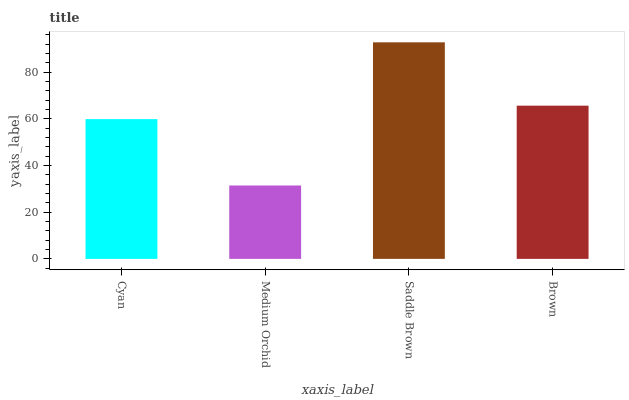Is Medium Orchid the minimum?
Answer yes or no. Yes. Is Saddle Brown the maximum?
Answer yes or no. Yes. Is Saddle Brown the minimum?
Answer yes or no. No. Is Medium Orchid the maximum?
Answer yes or no. No. Is Saddle Brown greater than Medium Orchid?
Answer yes or no. Yes. Is Medium Orchid less than Saddle Brown?
Answer yes or no. Yes. Is Medium Orchid greater than Saddle Brown?
Answer yes or no. No. Is Saddle Brown less than Medium Orchid?
Answer yes or no. No. Is Brown the high median?
Answer yes or no. Yes. Is Cyan the low median?
Answer yes or no. Yes. Is Cyan the high median?
Answer yes or no. No. Is Brown the low median?
Answer yes or no. No. 